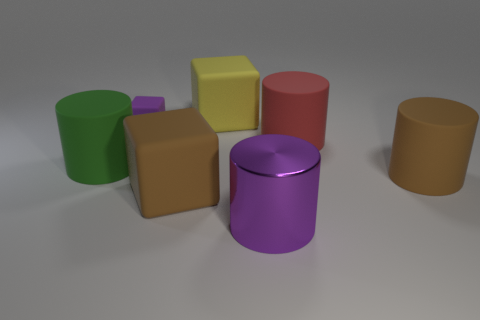There is a thing that is to the right of the large red rubber thing; does it have the same color as the big block in front of the purple rubber cube?
Your answer should be very brief. Yes. Are there any other things that are made of the same material as the large purple thing?
Make the answer very short. No. There is a brown rubber thing that is the same shape as the small purple object; what is its size?
Offer a terse response. Large. Is the number of rubber things in front of the yellow object greater than the number of brown matte cylinders?
Keep it short and to the point. Yes. Do the purple thing that is left of the brown block and the large brown cylinder have the same material?
Your answer should be compact. Yes. There is a purple object that is behind the purple thing that is right of the big brown thing that is left of the purple cylinder; what size is it?
Offer a terse response. Small. What size is the yellow block that is made of the same material as the green thing?
Give a very brief answer. Large. There is a large matte object that is in front of the large yellow cube and behind the large green cylinder; what is its color?
Offer a terse response. Red. Do the purple thing behind the green matte cylinder and the matte object that is behind the small rubber block have the same shape?
Offer a very short reply. Yes. What is the material of the large object behind the purple rubber cube?
Your answer should be very brief. Rubber. 